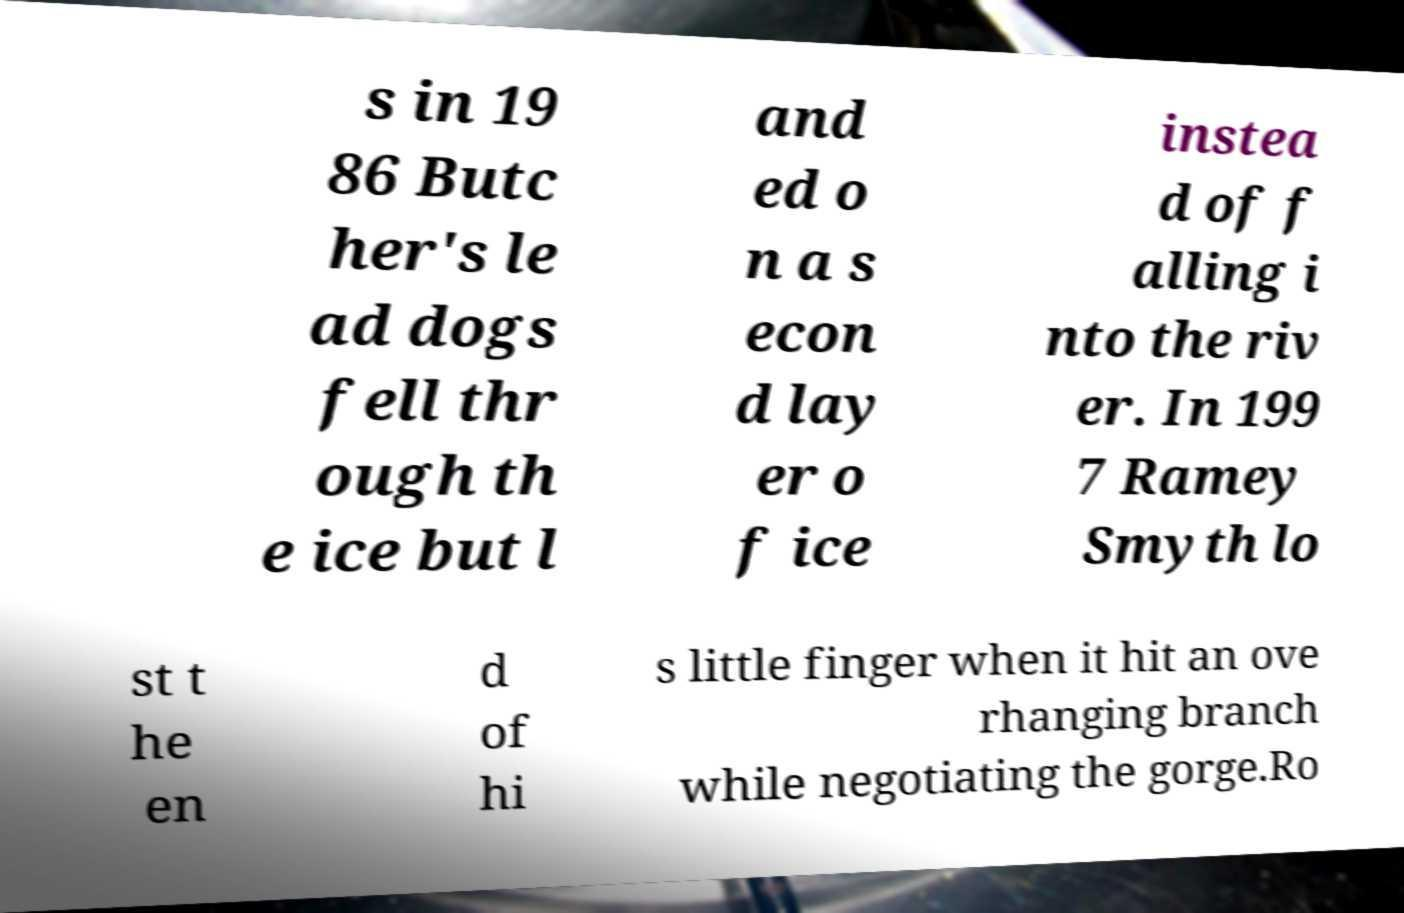What messages or text are displayed in this image? I need them in a readable, typed format. s in 19 86 Butc her's le ad dogs fell thr ough th e ice but l and ed o n a s econ d lay er o f ice instea d of f alling i nto the riv er. In 199 7 Ramey Smyth lo st t he en d of hi s little finger when it hit an ove rhanging branch while negotiating the gorge.Ro 